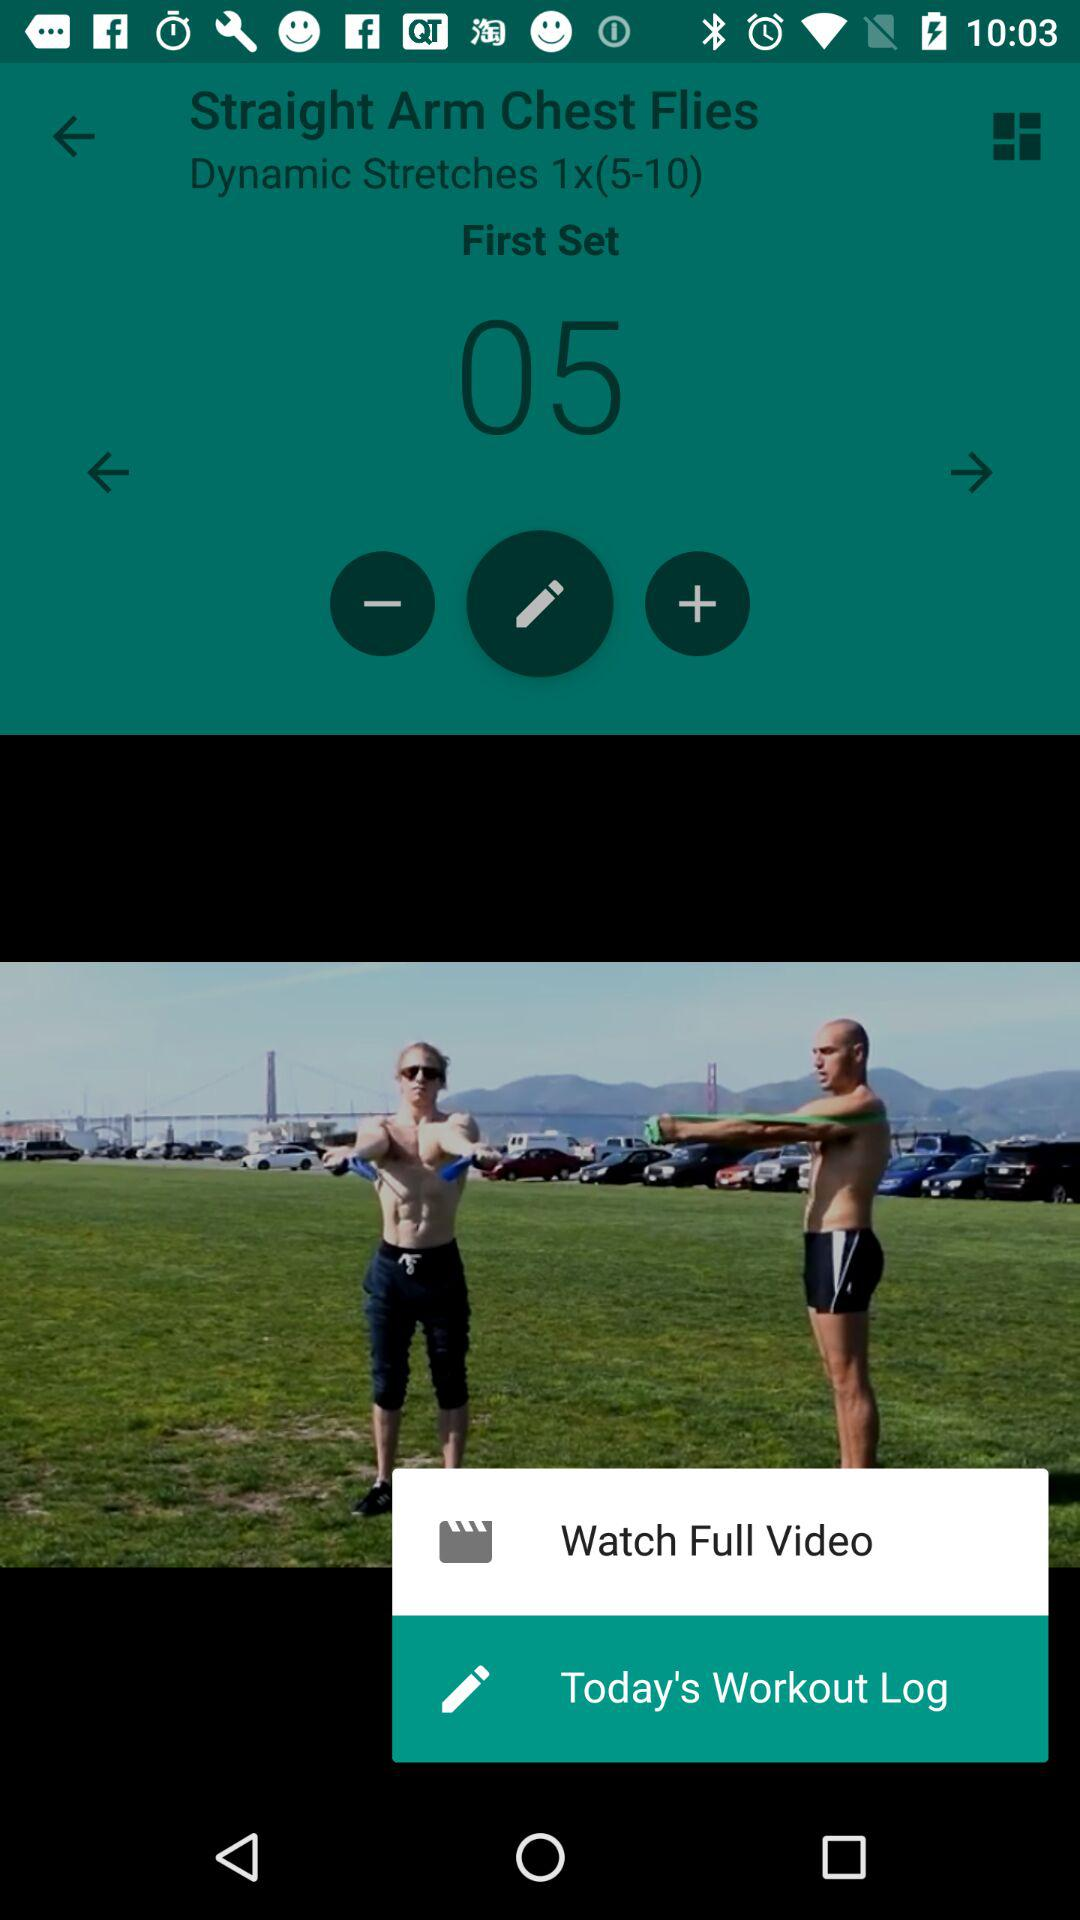What is the number of dynamic stretches?
When the provided information is insufficient, respond with <no answer>. <no answer> 